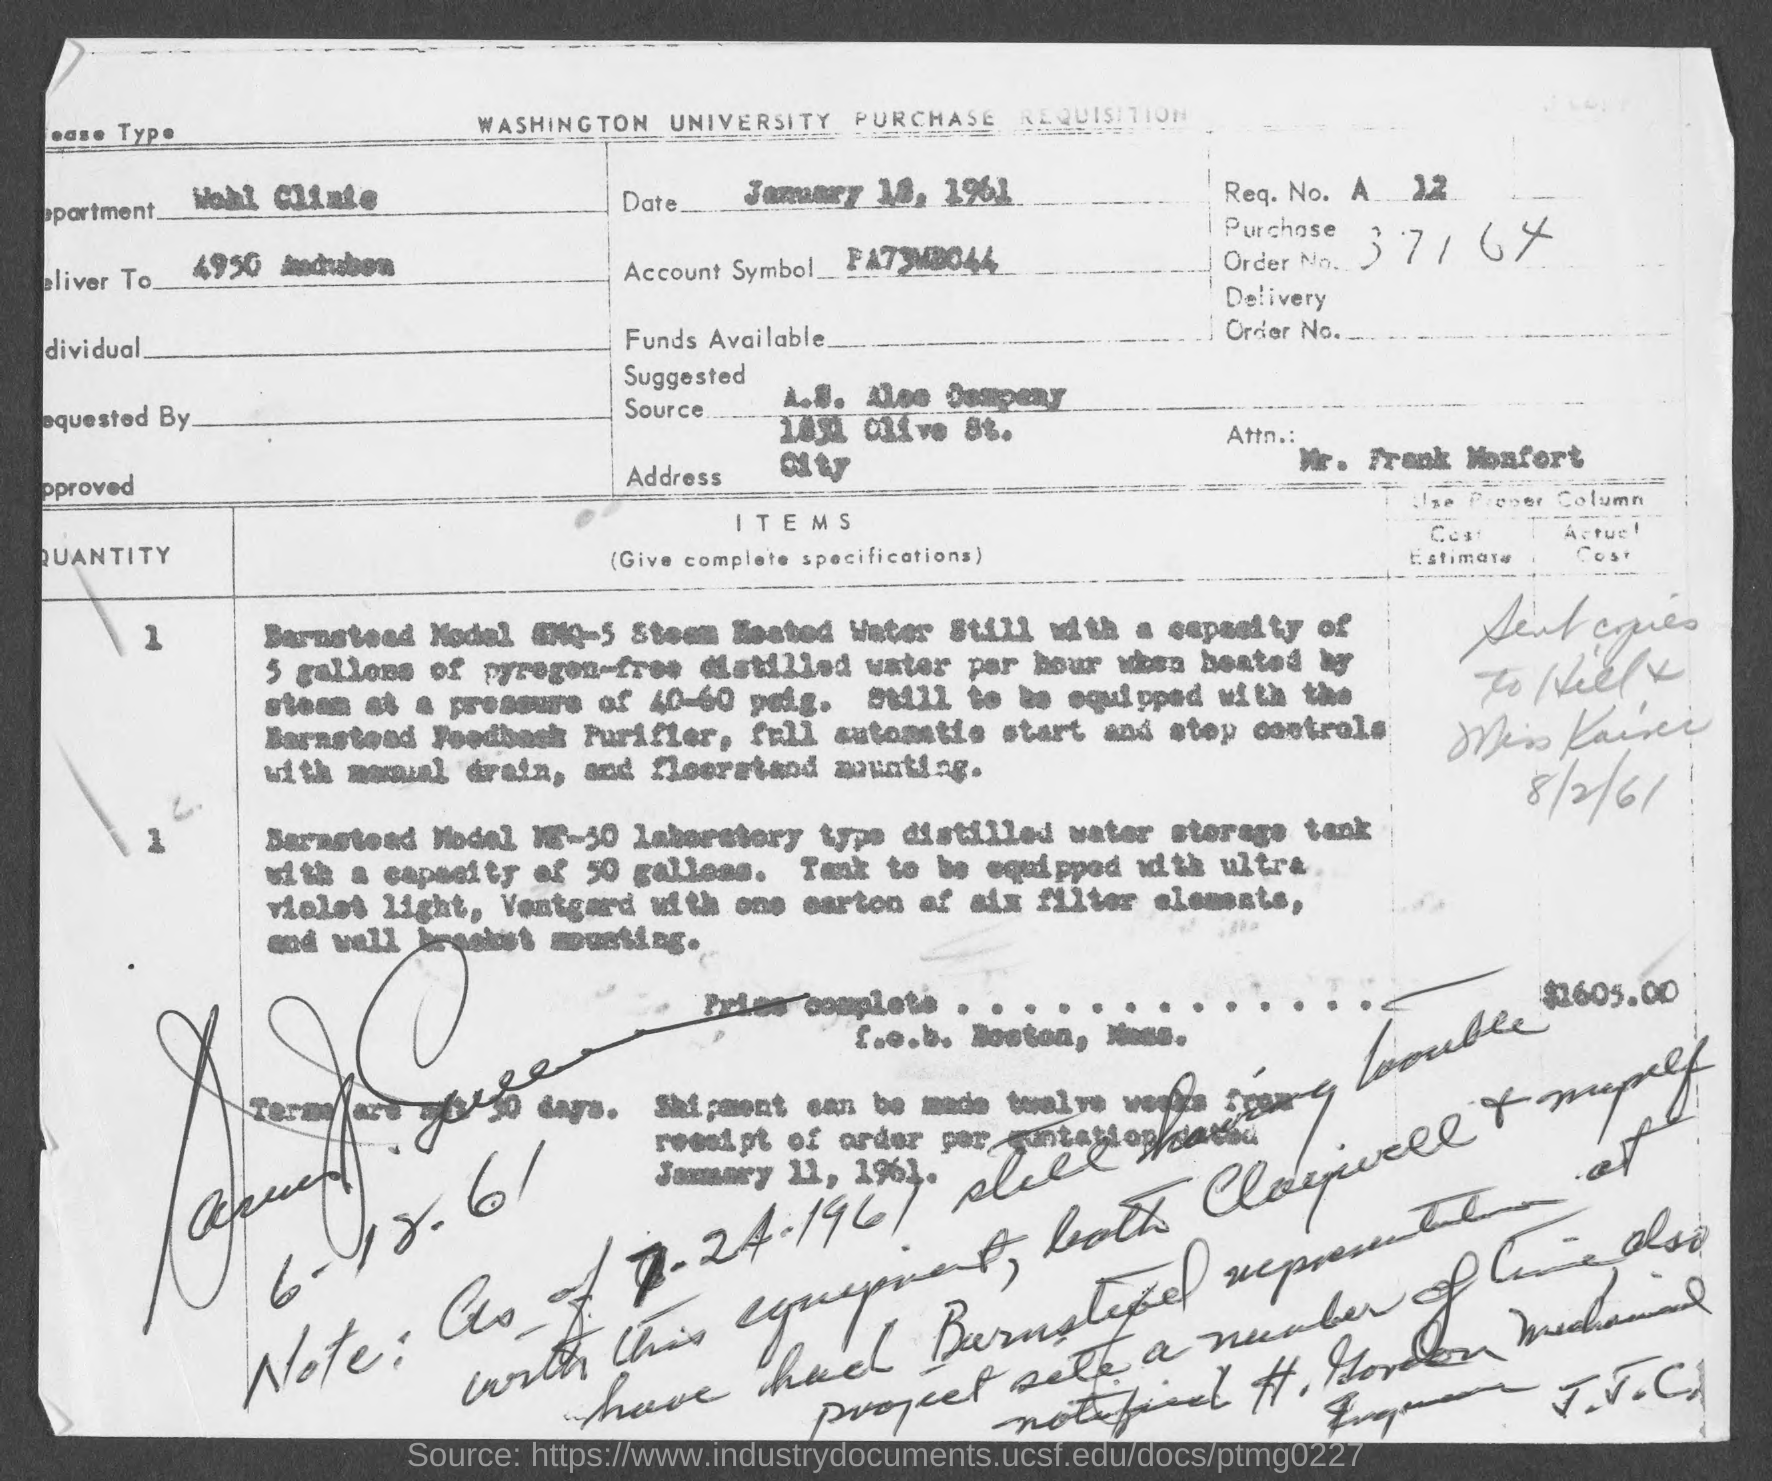What is the department?
Your answer should be very brief. Wohl Clinic. Who is the Attn. to?
Offer a terse response. Mr. Frank Monfort. 